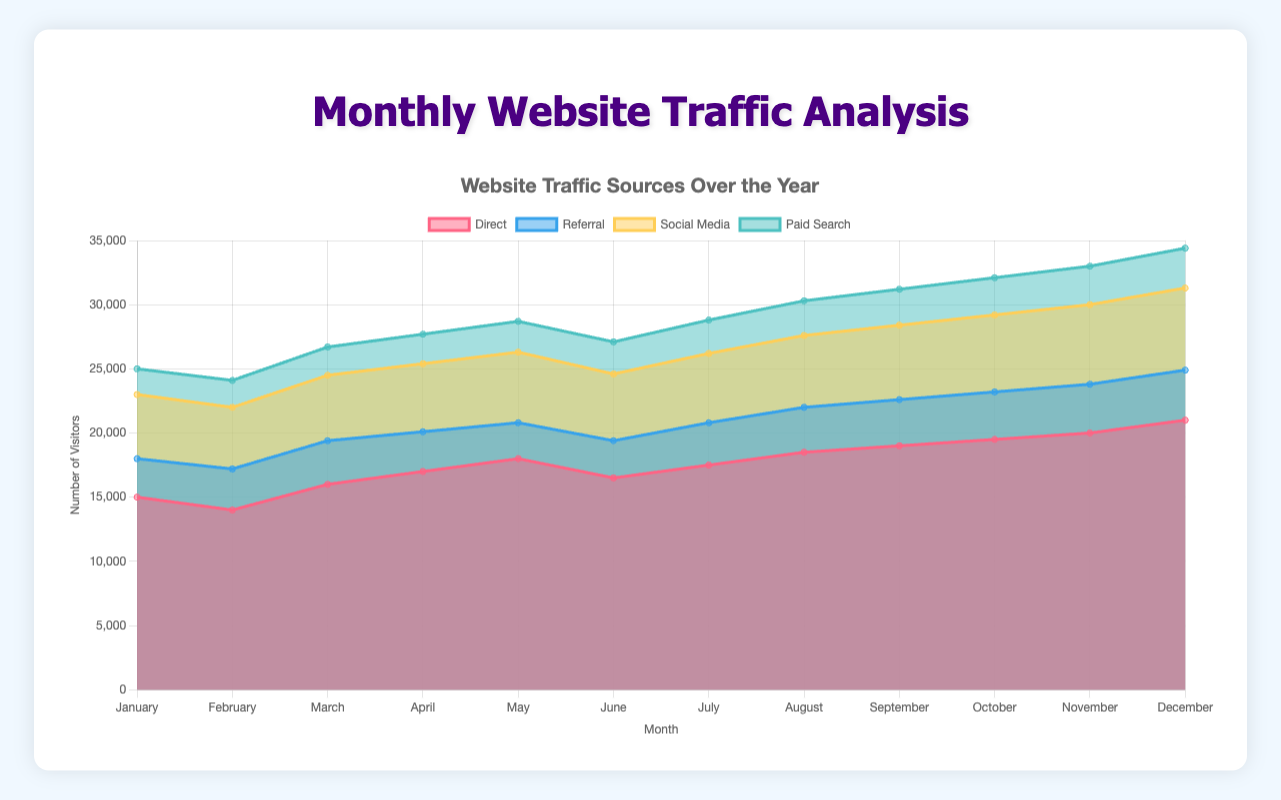What are the four sources of website traffic labeled in the figure? The figure has four different colored areas each representing a source of website traffic: Direct, Referral, Social Media, and Paid Search.
Answer: Direct, Referral, Social Media, Paid Search Which traffic source had the highest volume in December? In December, the highest volume is represented by the topmost and largest stacked area, which corresponds to Direct traffic.
Answer: Direct What is the overall trend of Direct traffic from January to December? By observing the area representing Direct traffic from January to December, it consistently increases month by month.
Answer: Increasing Which traffic source had a decrease in traffic from March to April? From March to April, the area representing Referral traffic decreases slightly.
Answer: Referral What is the total traffic for all sources in June? To find the total traffic in June, add the values of all sources for June: Direct (16500) + Referral (2900) + Social Media (5200) + Paid Search (2500). The sum is 16500 + 2900 + 5200 + 2500 = 27100.
Answer: 27100 Comparing May and September, which source of traffic showed the greatest increase? By comparing the values in May and September, the Paid Search traffic showed an increase from 2400 to 2800. The difference is 2800 - 2400 = 400, which is the highest among sources.
Answer: Paid Search What is the total increase in Direct traffic from January to December? The Direct traffic in January is 15000 and in December it is 21000. The increase is 21000 - 15000 = 6000.
Answer: 6000 For which months did Social Media traffic remain constant? Social Media traffic is represented by a consistently growing area; however, there are no two consecutive months in which the values stay the same.
Answer: None What is the average monthly traffic for Referral traffic over the year? By summing up the Referral traffic values for each month: 3000 + 3200 + 3400 + 3100 + 2800 + 2900 + 3300 + 3500 + 3600 + 3700 + 3800 + 3900 and dividing by the number of months (12), the calculation is (39000 / 12 = 3250).
Answer: 3250 During which month did Paid Search traffic surpass 2500 for the first time? Observing the Paid Search data, it first surpassed 2500 in June.
Answer: June 